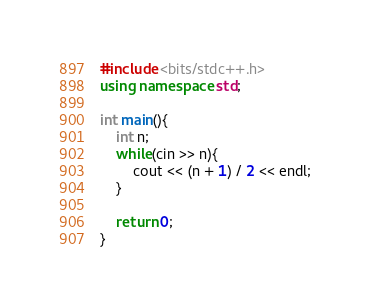<code> <loc_0><loc_0><loc_500><loc_500><_C++_>#include <bits/stdc++.h>
using namespace std;

int main(){
	int n;
	while(cin >> n){
		cout << (n + 1) / 2 << endl;
	}
	
	return 0;
}</code> 